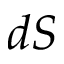<formula> <loc_0><loc_0><loc_500><loc_500>d S</formula> 